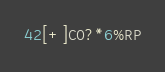<code> <loc_0><loc_0><loc_500><loc_500><_Awk_>42[+]C0?*6%RP</code> 